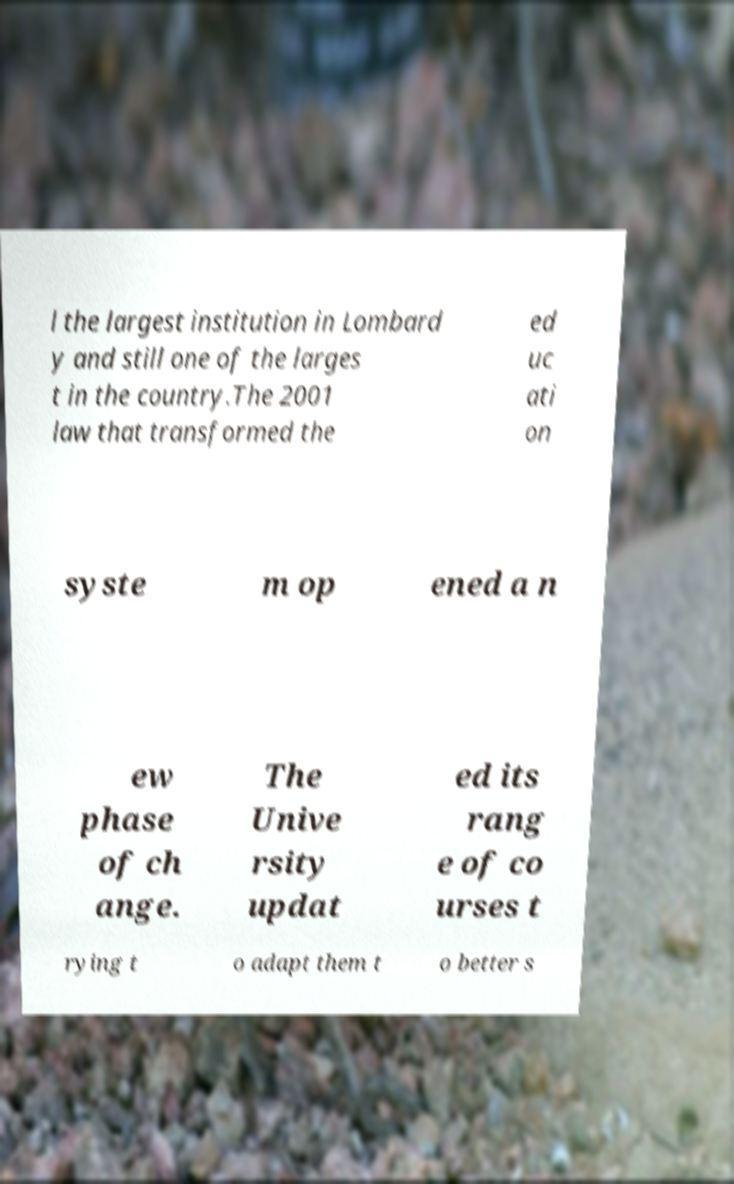Please identify and transcribe the text found in this image. l the largest institution in Lombard y and still one of the larges t in the country.The 2001 law that transformed the ed uc ati on syste m op ened a n ew phase of ch ange. The Unive rsity updat ed its rang e of co urses t rying t o adapt them t o better s 